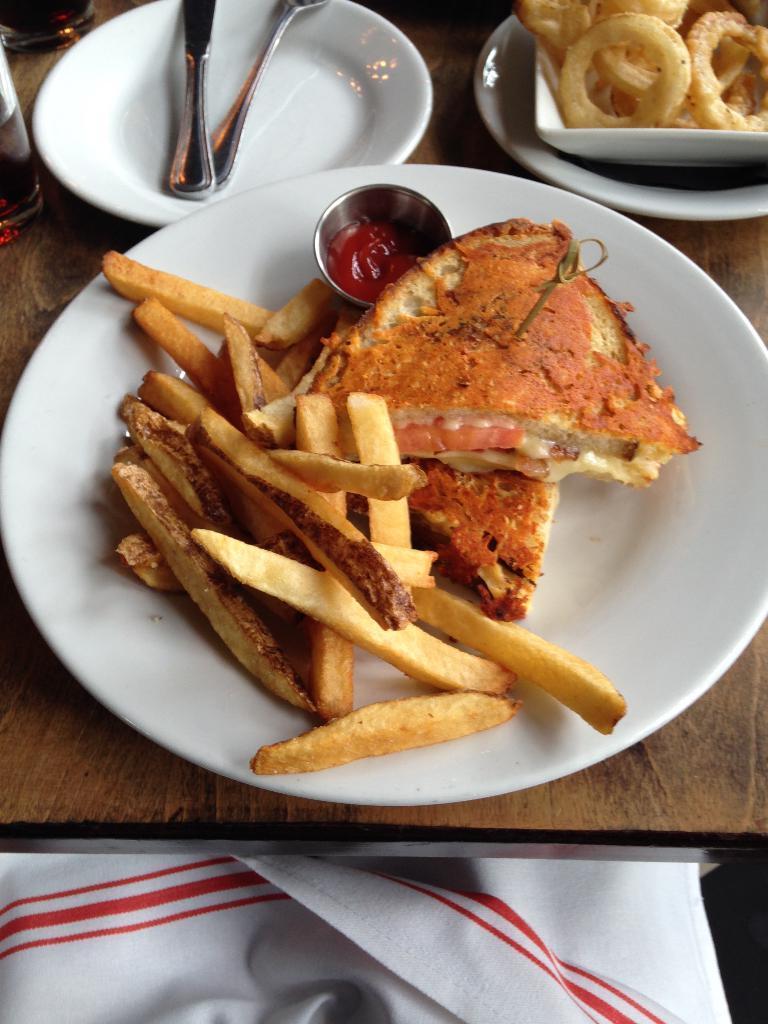Can you describe this image briefly? In the image I can see food items, spoons, a cup on white color plates and some other objects on a wooden surface. In front of the image I can see white color cloth which has red color lines. 